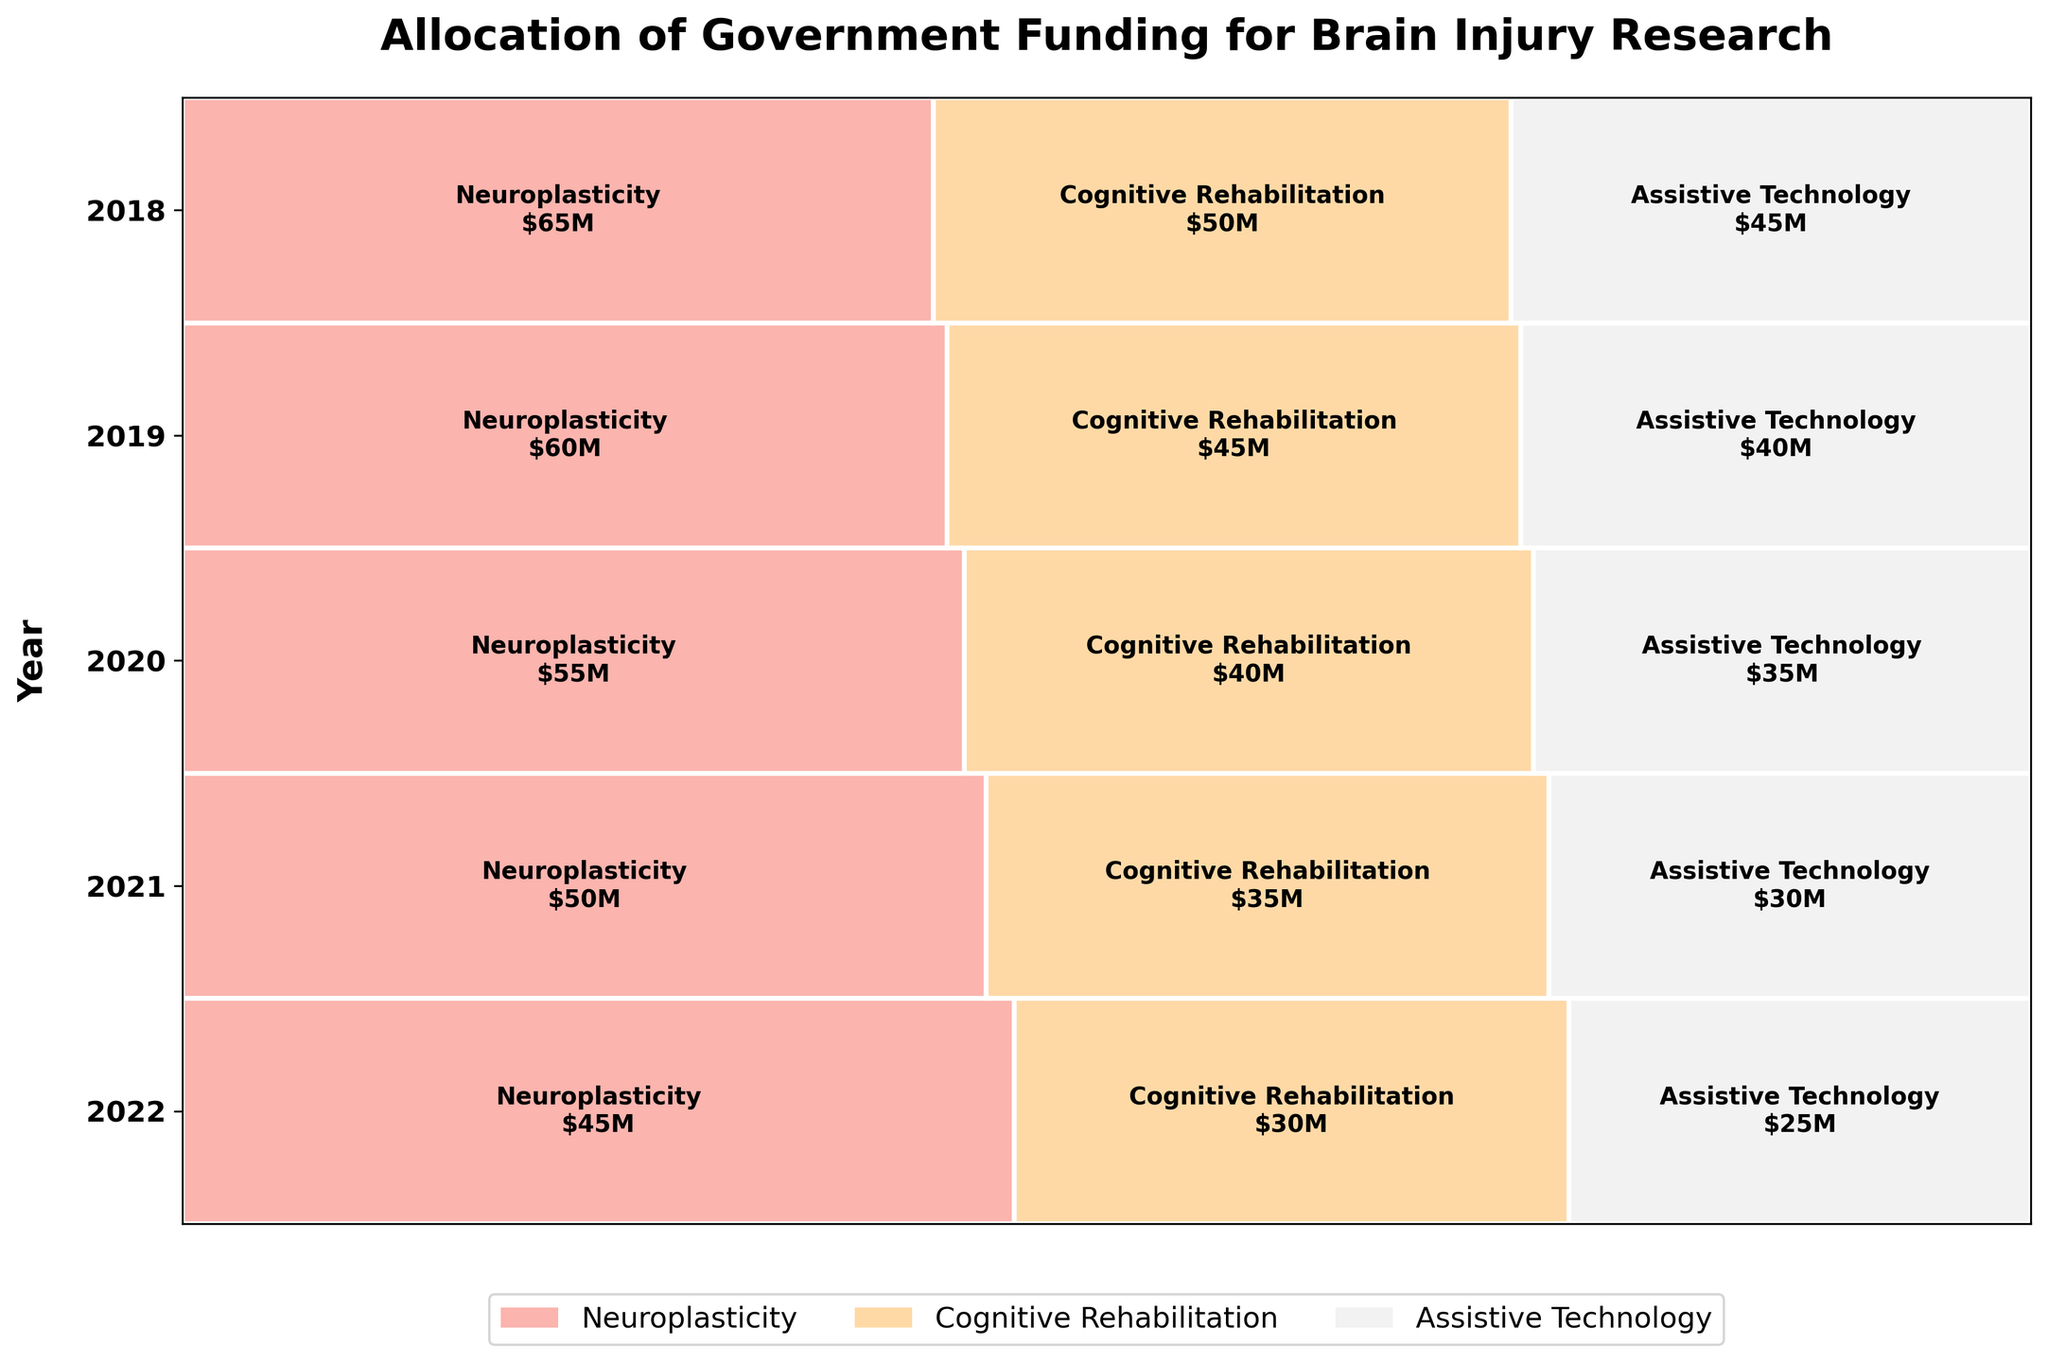What is the title of the figure? The title is displayed at the top of the figure in a larger, bold font. It summarizes the main focus of the plot, which in this case is about government funding allocation.
Answer: Allocation of Government Funding for Brain Injury Research Which year had the highest funding amount for Neuroplasticity? Observe the height and width of the rectangles labeled "Neuroplasticity" for each year. Note that the funding increases over the years, with 2022 having the widest rectangle labeled "Neuroplasticity."
Answer: 2022 How much funding did Assistive Technology receive in 2019? Find the row corresponding to the year 2019 and locate the rectangle for "Assistive Technology." The rectangle will have a label specifying the funding amount.
Answer: $30M How did the funding for Cognitive Rehabilitation change from 2018 to 2022? Compare the rectangles for "Cognitive Rehabilitation" in the years 2018 and 2022. Check the labels to see the specific funding amounts and calculate the difference.
Answer: Increased by $20M What is the total funding for the year 2020? Sum the funding amounts for Neuroplasticity, Cognitive Rehabilitation, and Assistive Technology in 2020. Based on the labels: $55M + $40M + $35M.
Answer: $130M Which research focus received the smallest share of funding in 2022? Look at the year 2022 and compare the widths of the rectangles. The smallest width corresponds to the smallest share.
Answer: Assistive Technology In 2021, which two research focuses had an equal share of funding? Observe the rectangles' widths for the year 2021. Identify if there are any rectangles with the same width.
Answer: Neuroplasticity and Assistive Technology What is the average annual funding for Cognitive Rehabilitation from 2018 to 2022? Sum the annual funding amounts for Cognitive Rehabilitation from 2018 to 2022 ($30M + $35M + $40M + $45M + $50M) and divide by the number of years (5).
Answer: $40M How much more funding did Neuroplasticity receive in 2022 compared to 2018? Compare the funding amounts for Neuroplasticity in 2018 and 2022. Subtract the amount in 2018 from the amount in 2022 ($65M - $45M).
Answer: $20M Which year showed the smallest total funding for brain injury research? Calculate the total funding for each year by summing the amounts for all research focuses and identify the year with the smallest sum.
Answer: 2018 